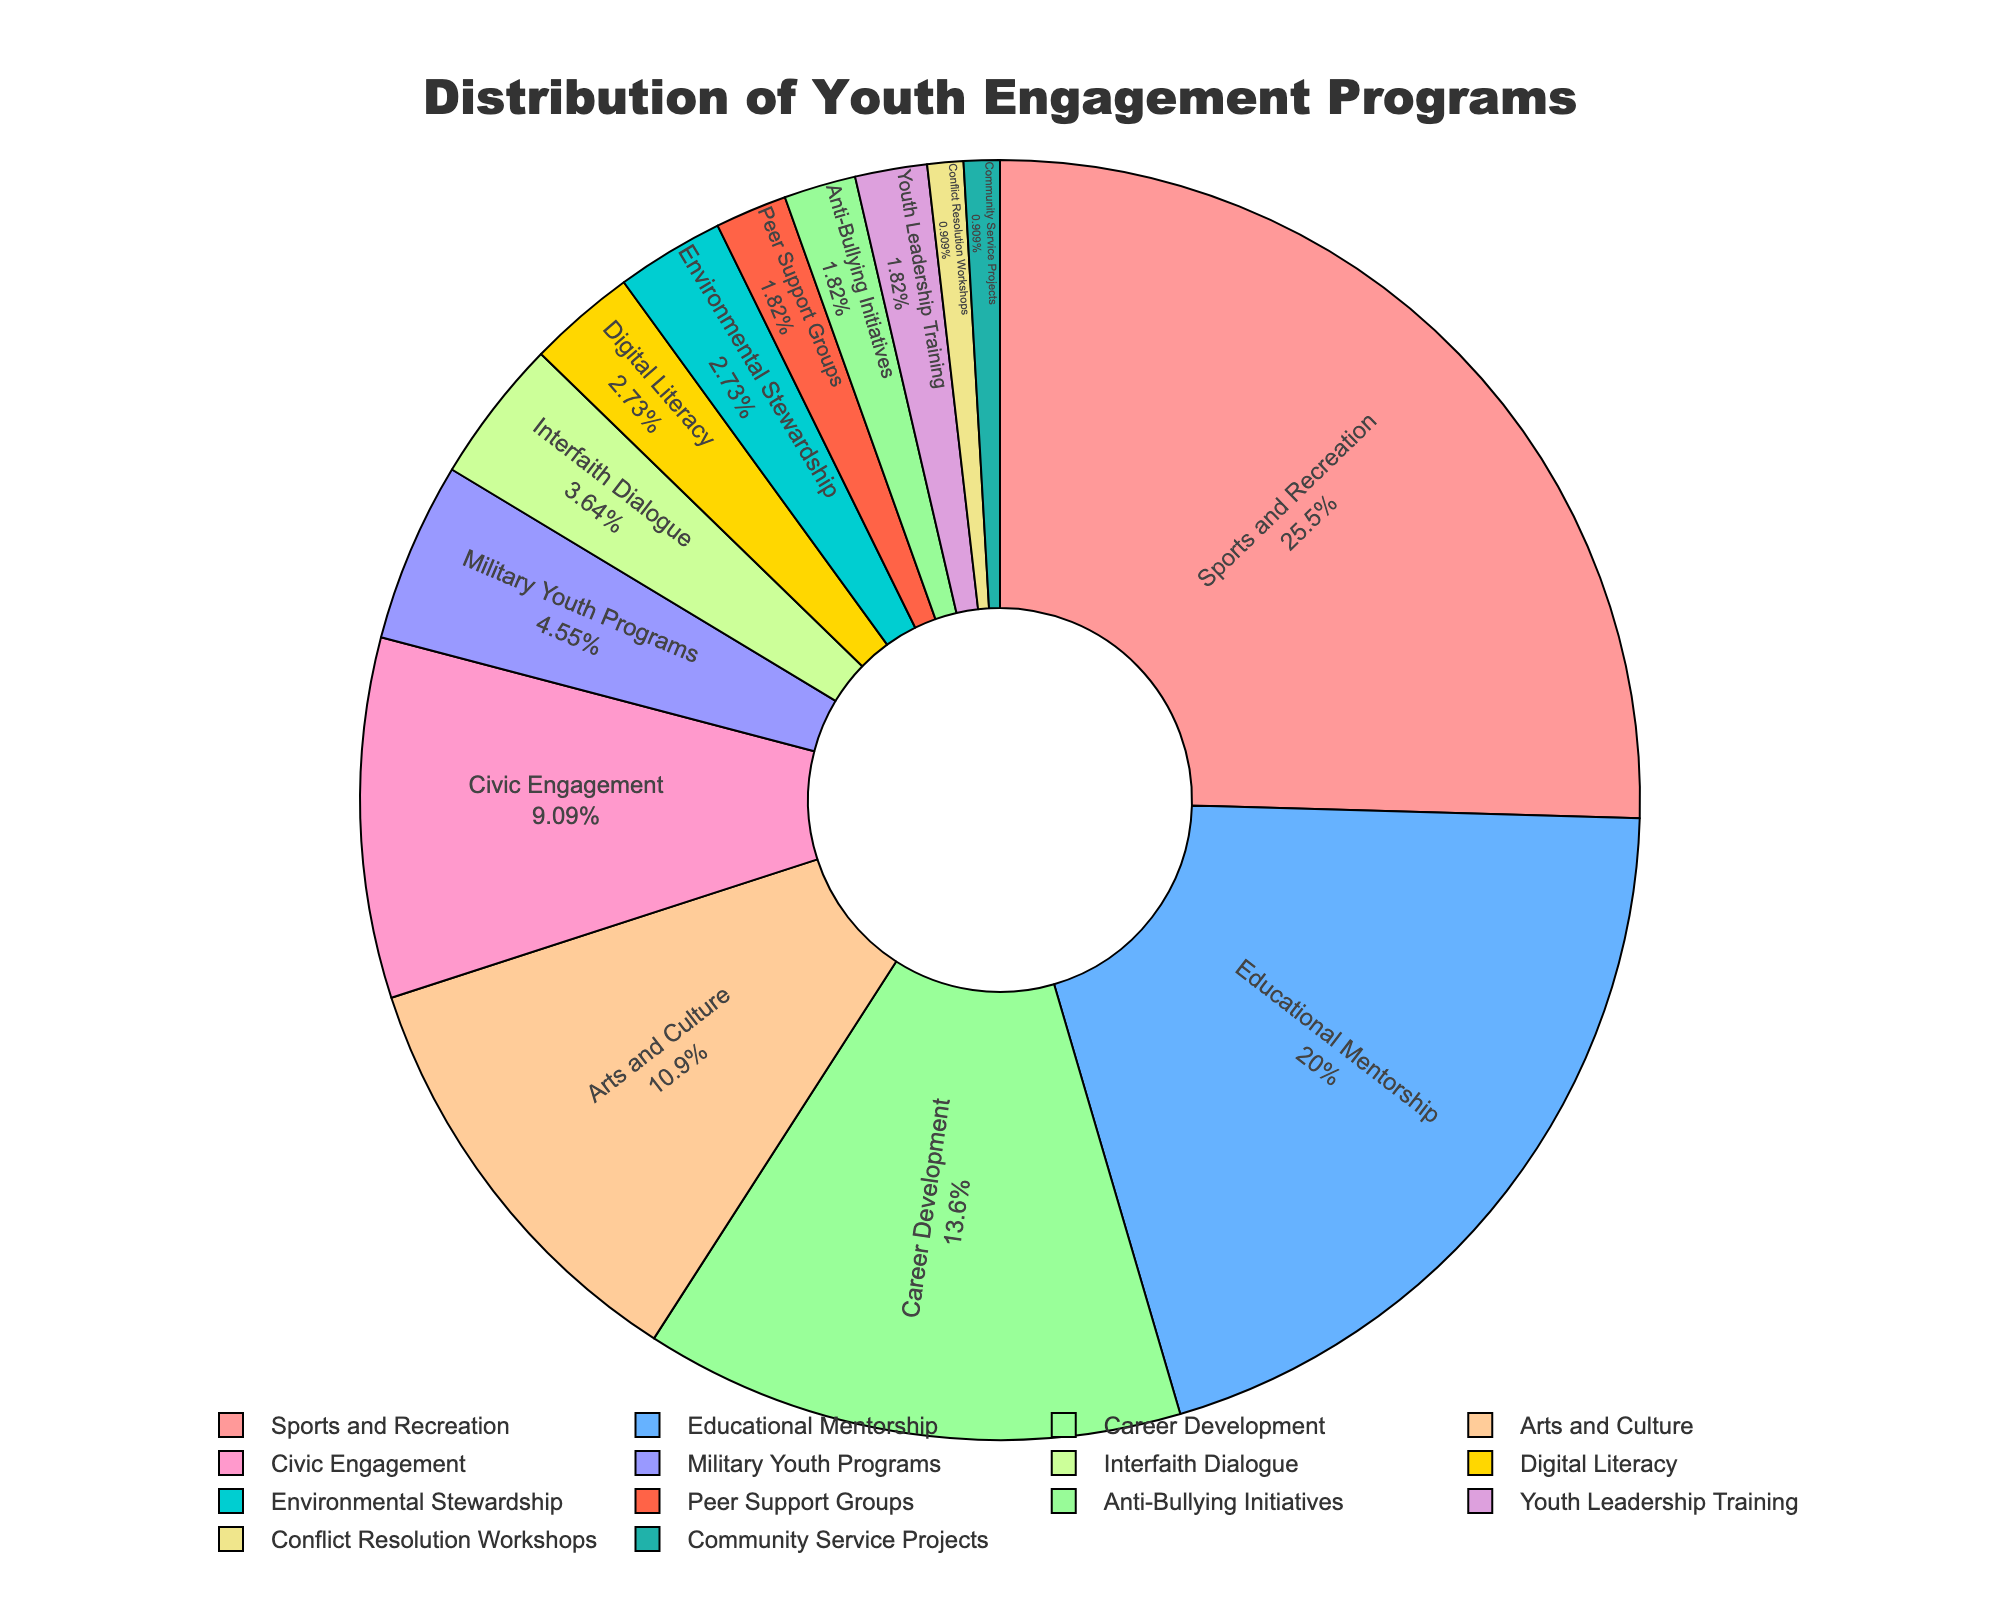What percentage of programs focus on Sports and Recreation and Educational Mentorship combined? The percentage for Sports and Recreation is 28%, and for Educational Mentorship, it's 22%. Adding them together gives 28 + 22 = 50%.
Answer: 50% Which program type has the least representation? The program types with the lowest percentages are Conflict Resolution Workshops and Community Service Projects at 1% each.
Answer: Conflict Resolution Workshops and Community Service Projects How much more represented are Sports and Recreation programs than Civic Engagement programs? Sports and Recreation have 28% whereas Civic Engagement has 10%. The difference between them is 28 - 10 = 18%.
Answer: 18% If you combine the percentages of Digital Literacy, Environmental Stewardship, Peer Support Groups, Anti-Bullying Initiatives, Youth Leadership Training, Conflict Resolution Workshops, and Community Service Projects, what is the total percentage? Adding the percentages: 3% + 3% + 2% + 2% + 2% + 1% + 1% = 14%.
Answer: 14% Which program type has the second highest percentage? The second highest percentage after Sports and Recreation (28%) are Educational Mentorship programs at 22%.
Answer: Educational Mentorship Of the programs colored yellow and blue, which has the higher percentage? From visual inspection, the Sports and Recreation programs are colored light red (28%), Educational Mentorship programs are light blue (22%), hence Educational Mentorship (22%) has the higher percentage among the two.
Answer: Educational Mentorship Does Arts and Culture programs have a larger percentage than Career Development programs? Arts and Culture programs have 12% while Career Development programs have 15%. Therefore, Career Development has a larger percentage than Arts and Culture.
Answer: No What fraction of the programs are either Interfaith Dialogue or Military Youth Programs? Interfaith Dialogue is 4% and Military Youth Programs is 5%. Adding them gives 4 + 5 = 9%. Therefore, the fraction is 9/100.
Answer: 9/100 Which programs make up more than 20% of the total distribution? The only programs above 20% are Sports and Recreation (28%) and Educational Mentorship (22%).
Answer: Sports and Recreation, Educational Mentorship Are Environmental Stewardship and Digital Literacy equally represented? Both Environmental Stewardship and Digital Literacy have a percentage of 3%, making them equally represented.
Answer: Yes 